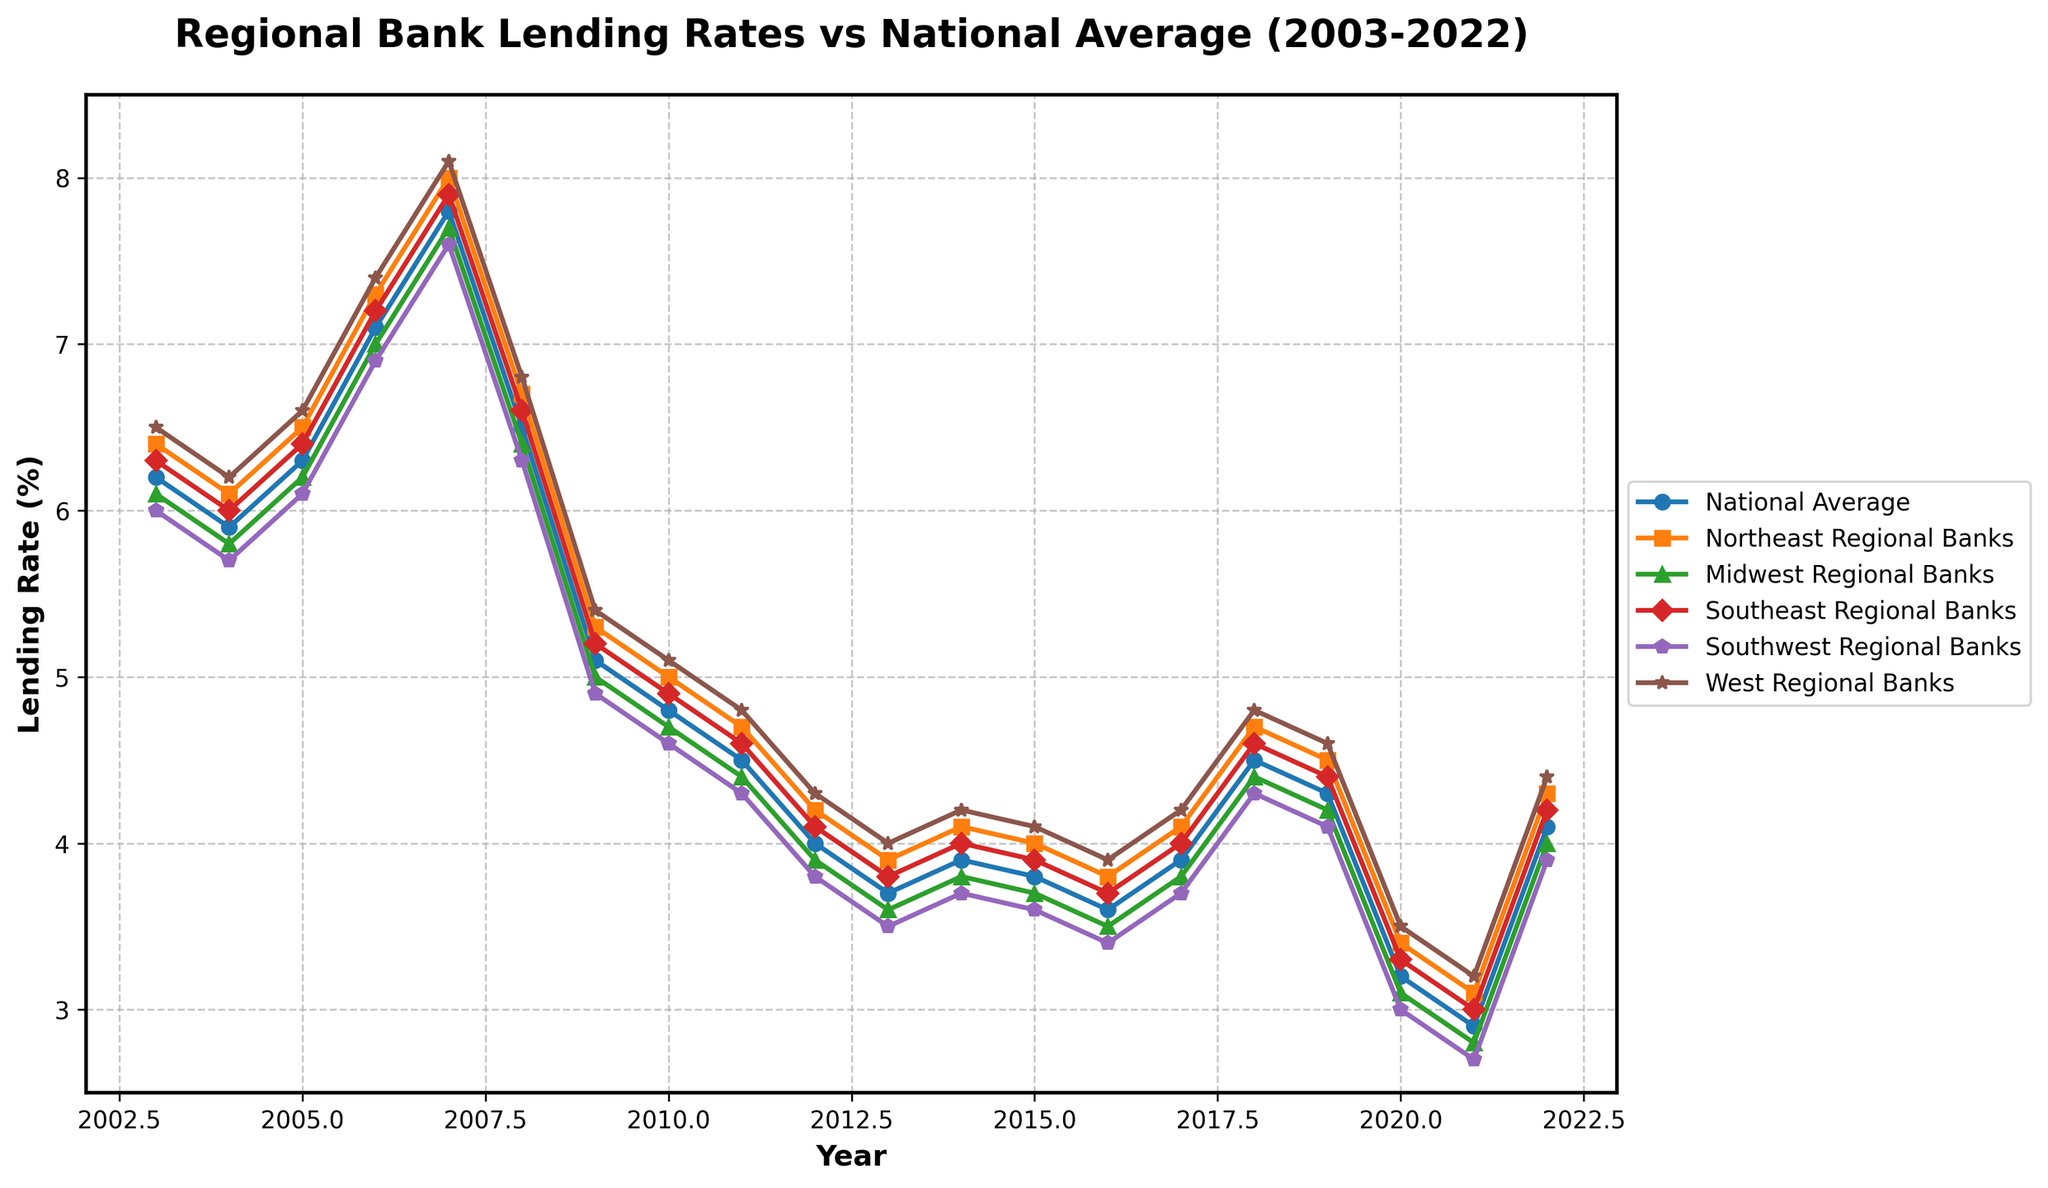What's the trend of the national average lending rate over the last 20 years? Look at the line representing the national average on the chart. It starts high around 6.2% in 2003, dips down to around 2.9% by 2021, and then rises to 4.1% by 2022.
Answer: Decreasing trend followed by a slight increase in the last few years What year did the lending rate peak for the Southeast Regional Banks? Locate the line corresponding to Southeast Regional Banks and find the highest point on that line. The highest point occurs in 2007.
Answer: 2007 By how many percentage points did the lending rate for Midwest Regional Banks decrease from 2006 to 2011? Find the lending rate for Midwest Regional Banks in 2006 (7.0%) and in 2011 (4.4%). Subtract the 2011 rate from the 2006 rate: 7.0% - 4.4%.
Answer: 2.6 percentage points In which year did the lending rate for the Southwest Regional Banks fall below 3%? Identify the line for Southwest Regional Banks and find the year when it first dips below 3%. It occurs in 2021.
Answer: 2021 Which region had the highest lending rate in 2009 and what was the rate? Look at the data points for each region in 2009. The West Regional Banks show the highest rate at 5.4%.
Answer: West Regional Banks, 5.4% During which years did the national average lending rate stay below 4%? Observe the national average line and identify the periods when the rate is below 4%. This happens from 2012 to 2017.
Answer: 2012-2017 Which region consistently had the highest lending rates compared to others? By glancing at the lines for each region across the entire timeframe, the West Regional Banks consistently have the highest rates among the regions.
Answer: West Regional Banks Calculate the average lending rate for the Northeast Regional Banks from 2003 to 2022. Sum the lending rates of the Northeast Regional Banks for each year (6.4 + 6.1 + 6.5 + 7.3 + 8.0 + 6.7 + 5.3 + 5.0 + 4.7 + 4.2 + 3.9 + 4.1 + 4.0 + 3.8 + 4.1 + 4.7 + 4.5 + 3.4 + 3.1 + 4.3) and divide by the number of years (20).
Answer: 5.0% Between what years did the lending rate for the National Average and Southeast Regional Banks appear to be the closest? Compare the lines for the national average and Southeast Regional Banks and find the smallest gap. This occurs between 2017 and 2019.
Answer: 2017-2019 